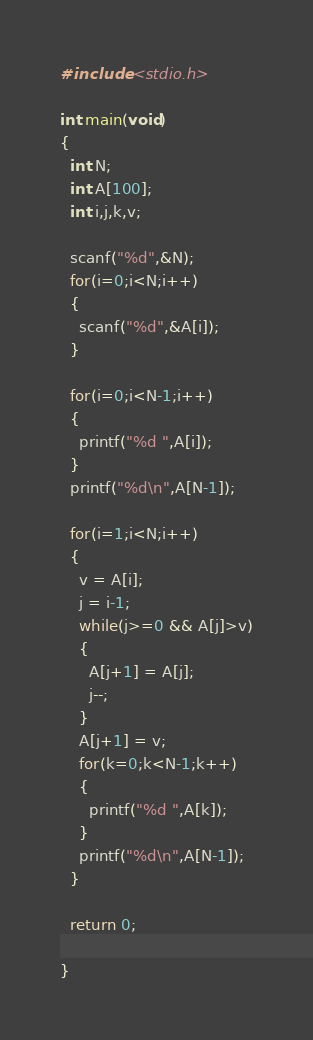Convert code to text. <code><loc_0><loc_0><loc_500><loc_500><_C_>#include <stdio.h>

int main(void)
{
  int N;
  int A[100];
  int i,j,k,v;

  scanf("%d",&N);
  for(i=0;i<N;i++)
  {
    scanf("%d",&A[i]);
  }

  for(i=0;i<N-1;i++)
  {
    printf("%d ",A[i]);
  }
  printf("%d\n",A[N-1]);

  for(i=1;i<N;i++)
  {
    v = A[i];
    j = i-1;
    while(j>=0 && A[j]>v)
    {
      A[j+1] = A[j];
      j--;
    }
    A[j+1] = v;
    for(k=0;k<N-1;k++)
    {
      printf("%d ",A[k]);
    }
    printf("%d\n",A[N-1]);
  }

  return 0;

}</code> 